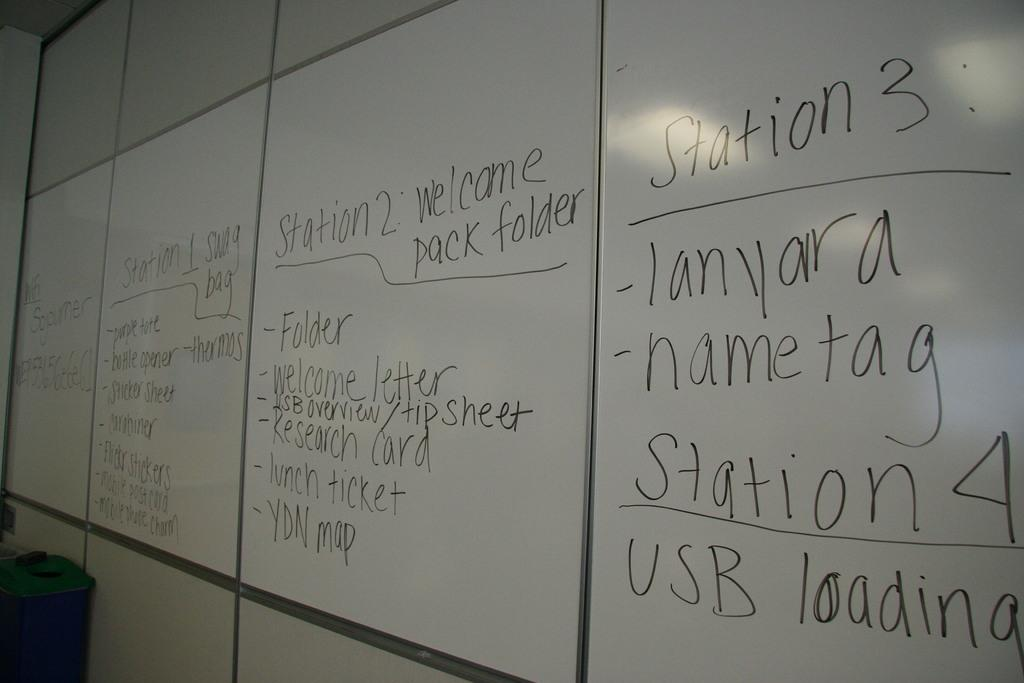Provide a one-sentence caption for the provided image. a white board has information about stations and lanyards on it. 